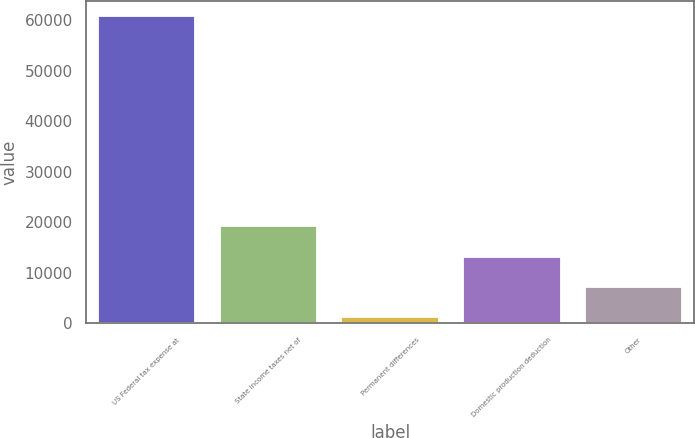Convert chart to OTSL. <chart><loc_0><loc_0><loc_500><loc_500><bar_chart><fcel>US Federal tax expense at<fcel>State income taxes net of<fcel>Permanent differences<fcel>Domestic production deduction<fcel>Other<nl><fcel>60717<fcel>19155.9<fcel>1344<fcel>13218.6<fcel>7281.3<nl></chart> 